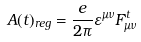<formula> <loc_0><loc_0><loc_500><loc_500>A ( t ) _ { r e g } = \frac { e } { 2 \pi } \varepsilon ^ { \mu \nu } F _ { \mu \nu } ^ { t }</formula> 